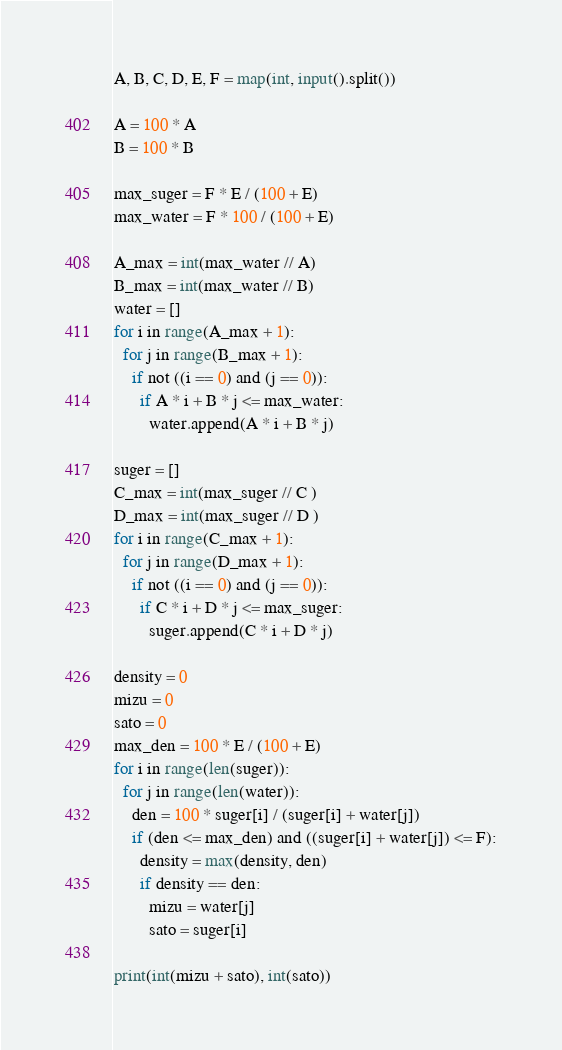<code> <loc_0><loc_0><loc_500><loc_500><_Python_>A, B, C, D, E, F = map(int, input().split())

A = 100 * A
B = 100 * B

max_suger = F * E / (100 + E)
max_water = F * 100 / (100 + E)

A_max = int(max_water // A)
B_max = int(max_water // B)
water = []
for i in range(A_max + 1):
  for j in range(B_max + 1):
    if not ((i == 0) and (j == 0)):
      if A * i + B * j <= max_water:
        water.append(A * i + B * j)
      
suger = []
C_max = int(max_suger // C )
D_max = int(max_suger // D )
for i in range(C_max + 1):
  for j in range(D_max + 1):
    if not ((i == 0) and (j == 0)):
      if C * i + D * j <= max_suger:
        suger.append(C * i + D * j)  
    
density = 0
mizu = 0
sato = 0
max_den = 100 * E / (100 + E)
for i in range(len(suger)):
  for j in range(len(water)):
    den = 100 * suger[i] / (suger[i] + water[j])
    if (den <= max_den) and ((suger[i] + water[j]) <= F):
      density = max(density, den)
      if density == den:
        mizu = water[j]
        sato = suger[i]

print(int(mizu + sato), int(sato))</code> 